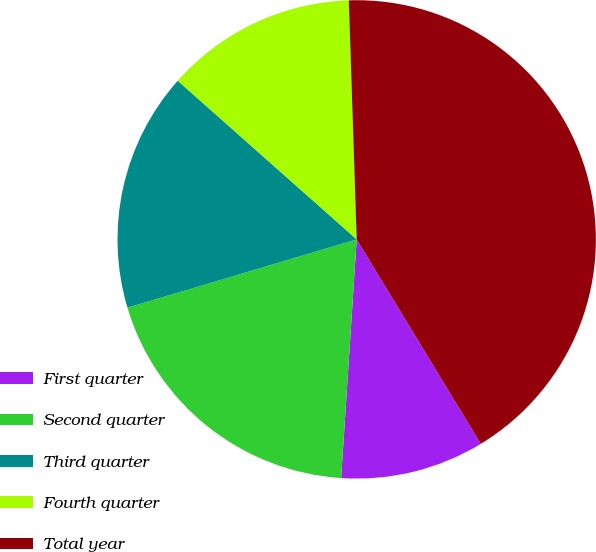<chart> <loc_0><loc_0><loc_500><loc_500><pie_chart><fcel>First quarter<fcel>Second quarter<fcel>Third quarter<fcel>Fourth quarter<fcel>Total year<nl><fcel>9.72%<fcel>19.36%<fcel>16.15%<fcel>12.93%<fcel>41.84%<nl></chart> 